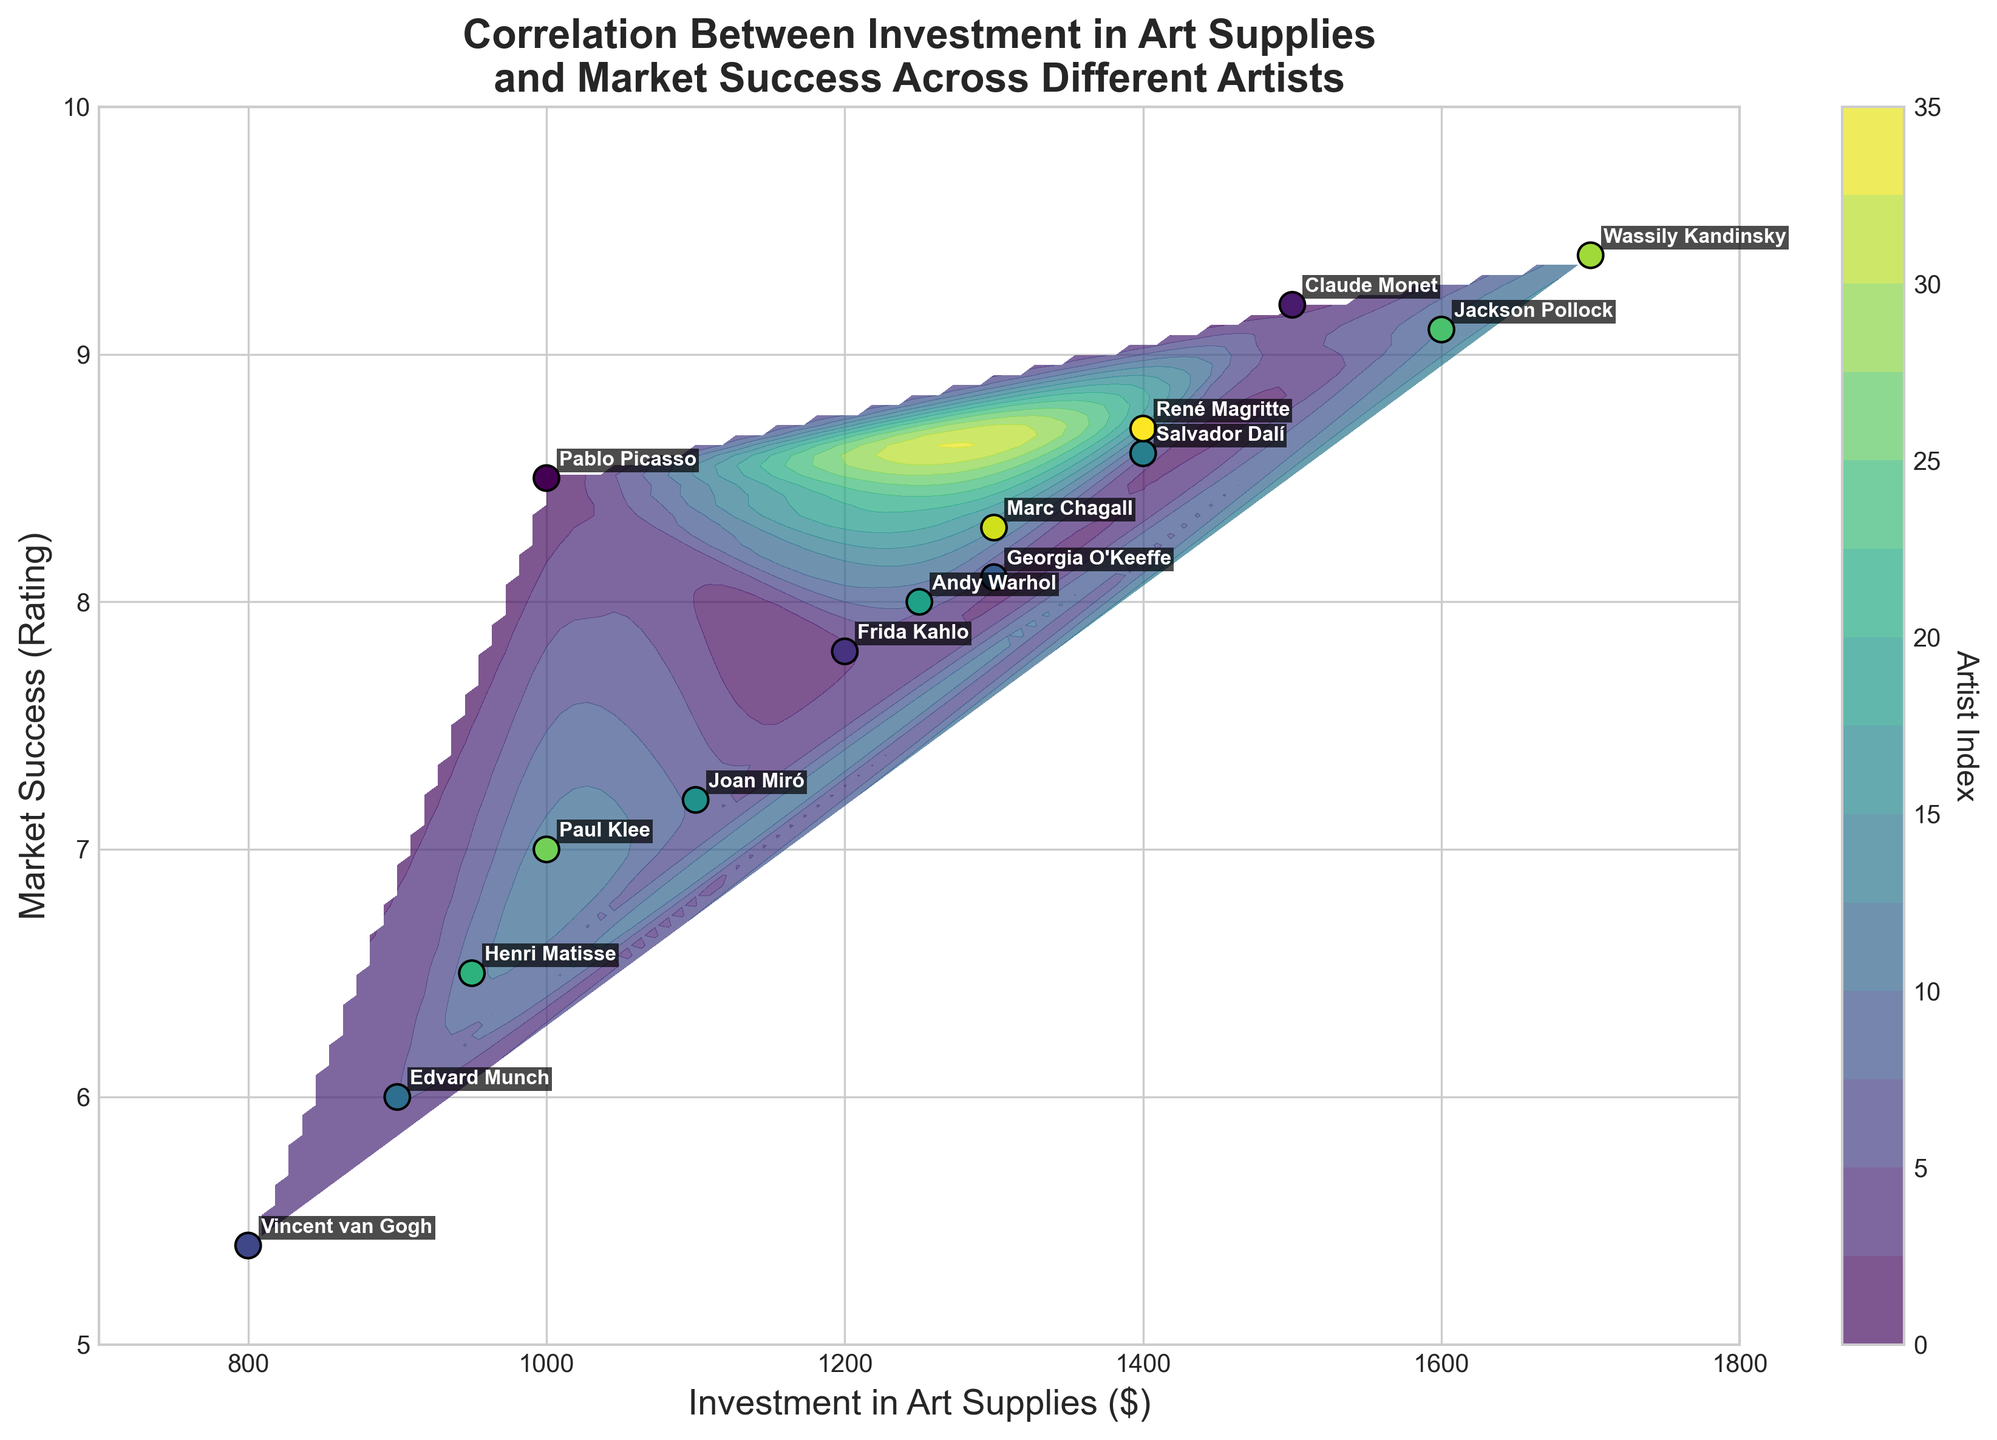What is the title of the figure? The title is located at the top center of the plot, which summarizes the study or visualization being presented.
Answer: Correlation Between Investment in Art Supplies and Market Success Across Different Artists What does the x-axis represent? The x-axis label is placed horizontally below the bottom axis line of the plot, explaining what is measured along this axis.
Answer: Investment in Art Supplies ($) How many data points are shown on the plot? Each artist's investment and market success are represented as a scatter point on the plot. By counting these points, we find the total number of data points.
Answer: 15 Which artist has the highest market success rating, and what is that rating? By looking at the highest value on the y-axis and checking the nearby labeled scatter points, we can identify the artist with the highest rating.
Answer: Wassily Kandinsky, 9.4 Which artists have invested exactly $1000 in art supplies? By finding the points on the plot where the x-coordinate is $1000 and reading the labels next to them, we identify the artists.
Answer: Pablo Picasso, Paul Klee What is the general trend indicated by the contour lines in terms of investment and market success? The contour lines represent levels of artist indices. Observing their gradient and direction needs interpretation. Generally, higher investments correlate with higher market success.
Answer: Positive Correlation Which artist had a lower market success even with a high investment, say around $1500? To answer this, look near $1500 on the x-axis and check which artist falls relatively lower on the y-axis (market success) compared to others.
Answer: Claude Monet Who invested the least in art supplies, and what was their market success rating? By identifying the lowest x-axis value and checking the corresponding y-axis label, the artist with the least investment and their rating can be found.
Answer: Vincent van Gogh, 5.4 Which two artists have almost equal market success but different levels of investment? Look for closely clustered points on the y-axis that have a noticeable distance between each other on the x-axis, then read their labels.
Answer: Frida Kahlo and Joan Miró What is the relationship between the contour colors and the scatter point decorations? Contour colors represent underlying artist indices interpolated in the grid data. Scatter points are the actual artist data with the same color map, providing a correlation between the real and grid-interpolated data.
Answer: Contours reflect artist indices 